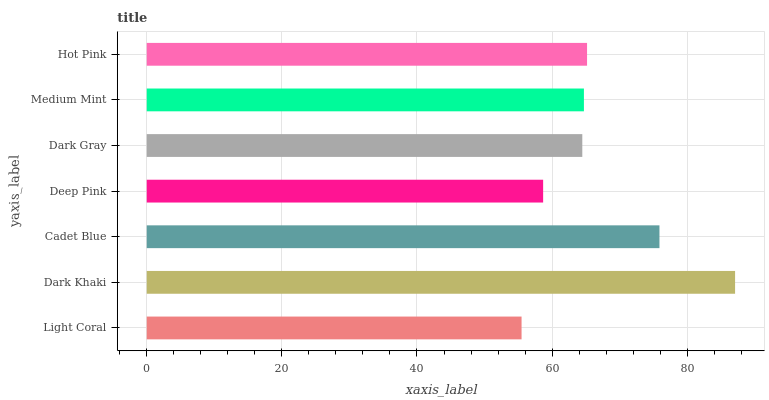Is Light Coral the minimum?
Answer yes or no. Yes. Is Dark Khaki the maximum?
Answer yes or no. Yes. Is Cadet Blue the minimum?
Answer yes or no. No. Is Cadet Blue the maximum?
Answer yes or no. No. Is Dark Khaki greater than Cadet Blue?
Answer yes or no. Yes. Is Cadet Blue less than Dark Khaki?
Answer yes or no. Yes. Is Cadet Blue greater than Dark Khaki?
Answer yes or no. No. Is Dark Khaki less than Cadet Blue?
Answer yes or no. No. Is Medium Mint the high median?
Answer yes or no. Yes. Is Medium Mint the low median?
Answer yes or no. Yes. Is Dark Gray the high median?
Answer yes or no. No. Is Light Coral the low median?
Answer yes or no. No. 